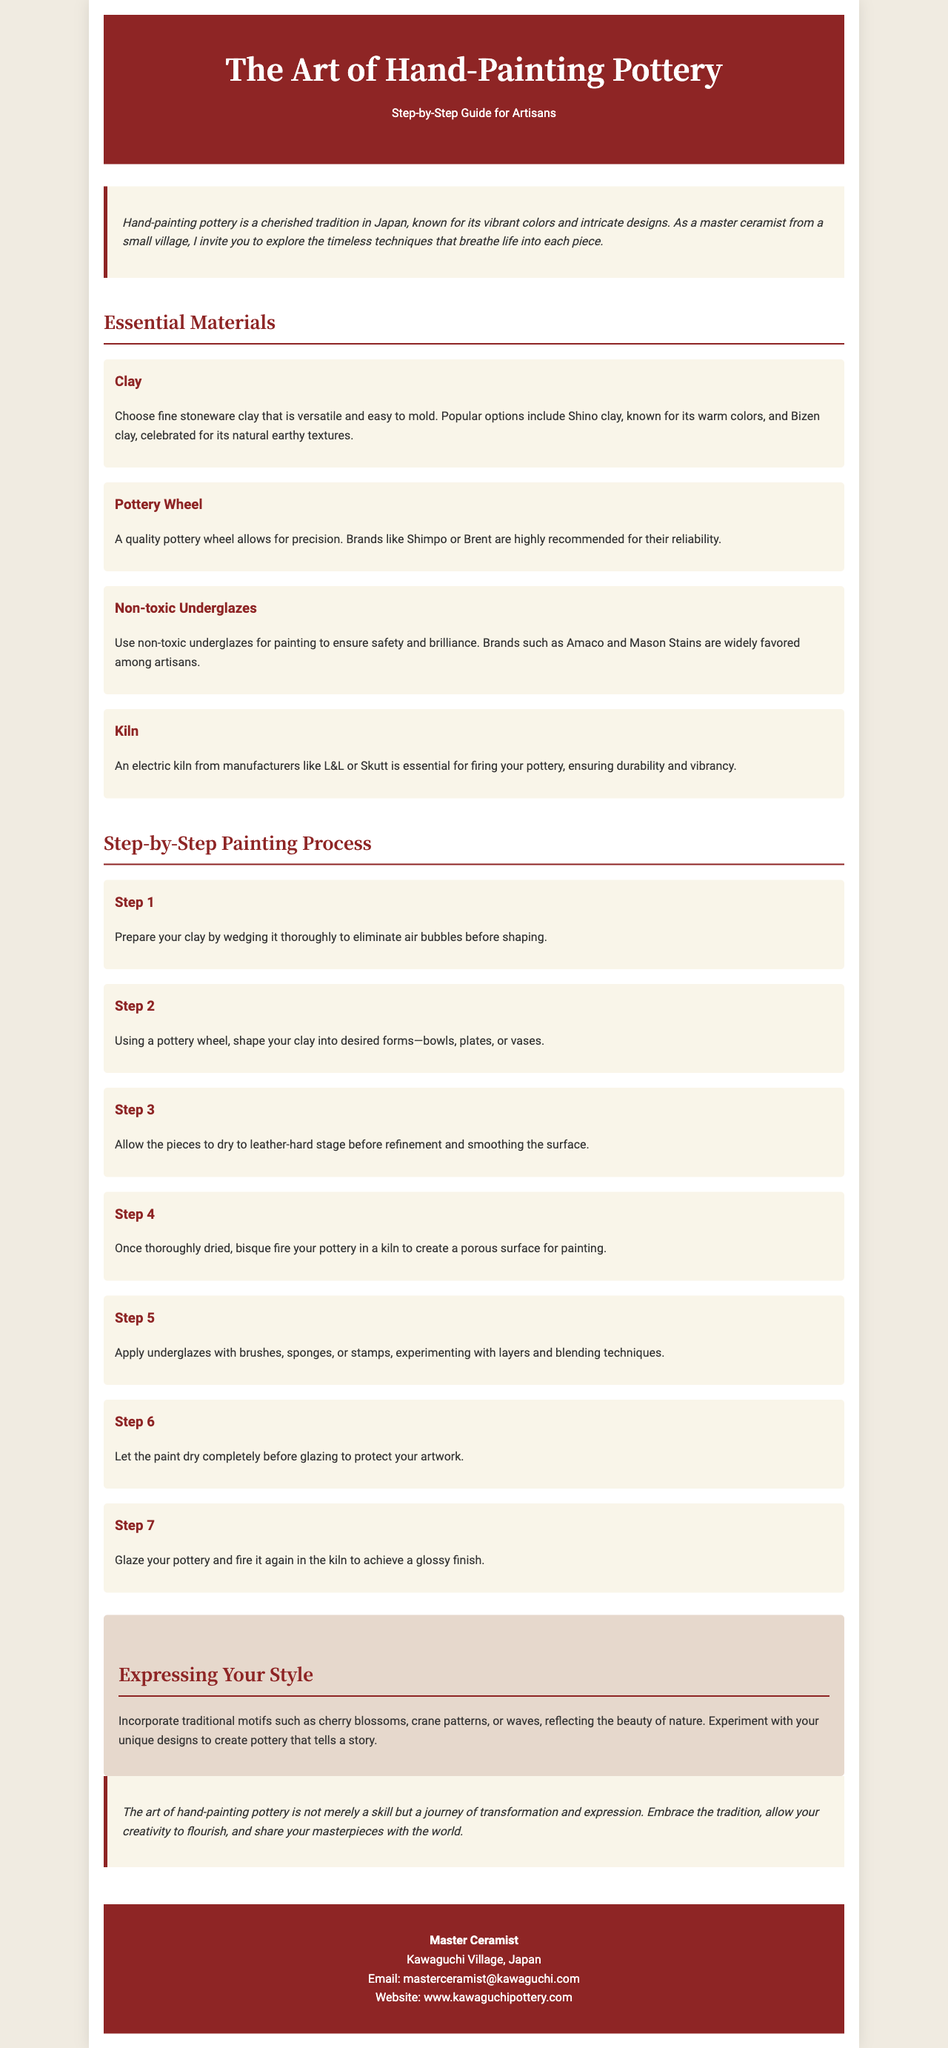what is the title of the brochure? The title is the main header at the top of the document.
Answer: The Art of Hand-Painting Pottery who is the author of the brochure? The author is indicated at the footer section of the document.
Answer: Master Ceramist what is the purpose of the document? The purpose of the document is described in the introductory section.
Answer: Step-by-Step Guide for Artisans how many essential materials are listed in the document? The number of materials is determined by counting the listed items in the essential materials section.
Answer: Four what is the first step in the painting process? The first step is described in the numbered steps in the painting process section.
Answer: Prepare your clay by wedging it thoroughly what type of clay is recommended? The document specifies the clay type in the materials section.
Answer: Fine stoneware clay what color is used for the header background? The header background color is referred to in the styling section.
Answer: #8e2525 what motifs are suggested for personalization? The document highlights motifs in the express style section.
Answer: Cherry blossoms, crane patterns, or waves what should you do after applying underglazes? The document mentions this in the painting process section.
Answer: Let the paint dry completely before glazing 